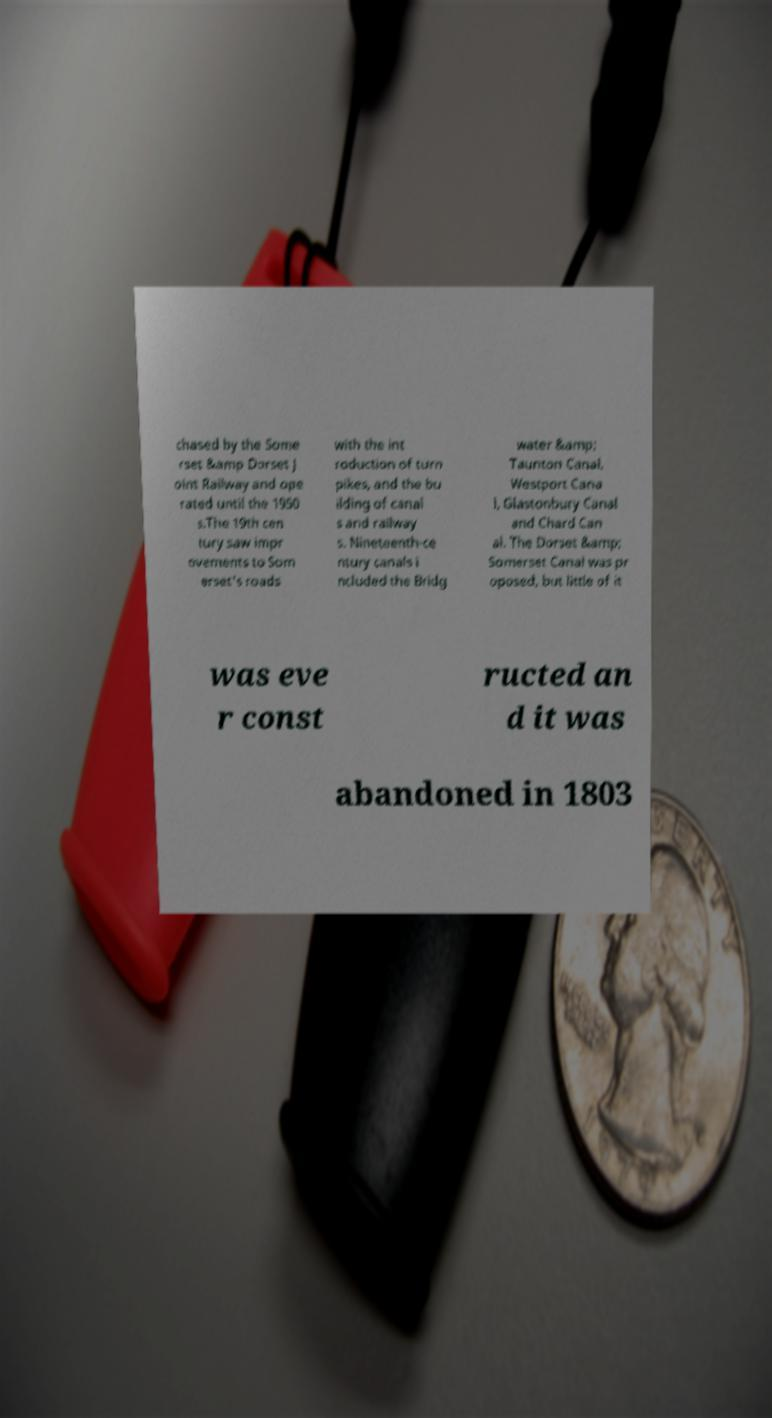Can you accurately transcribe the text from the provided image for me? chased by the Some rset &amp Dorset J oint Railway and ope rated until the 1950 s.The 19th cen tury saw impr ovements to Som erset's roads with the int roduction of turn pikes, and the bu ilding of canal s and railway s. Nineteenth-ce ntury canals i ncluded the Bridg water &amp; Taunton Canal, Westport Cana l, Glastonbury Canal and Chard Can al. The Dorset &amp; Somerset Canal was pr oposed, but little of it was eve r const ructed an d it was abandoned in 1803 